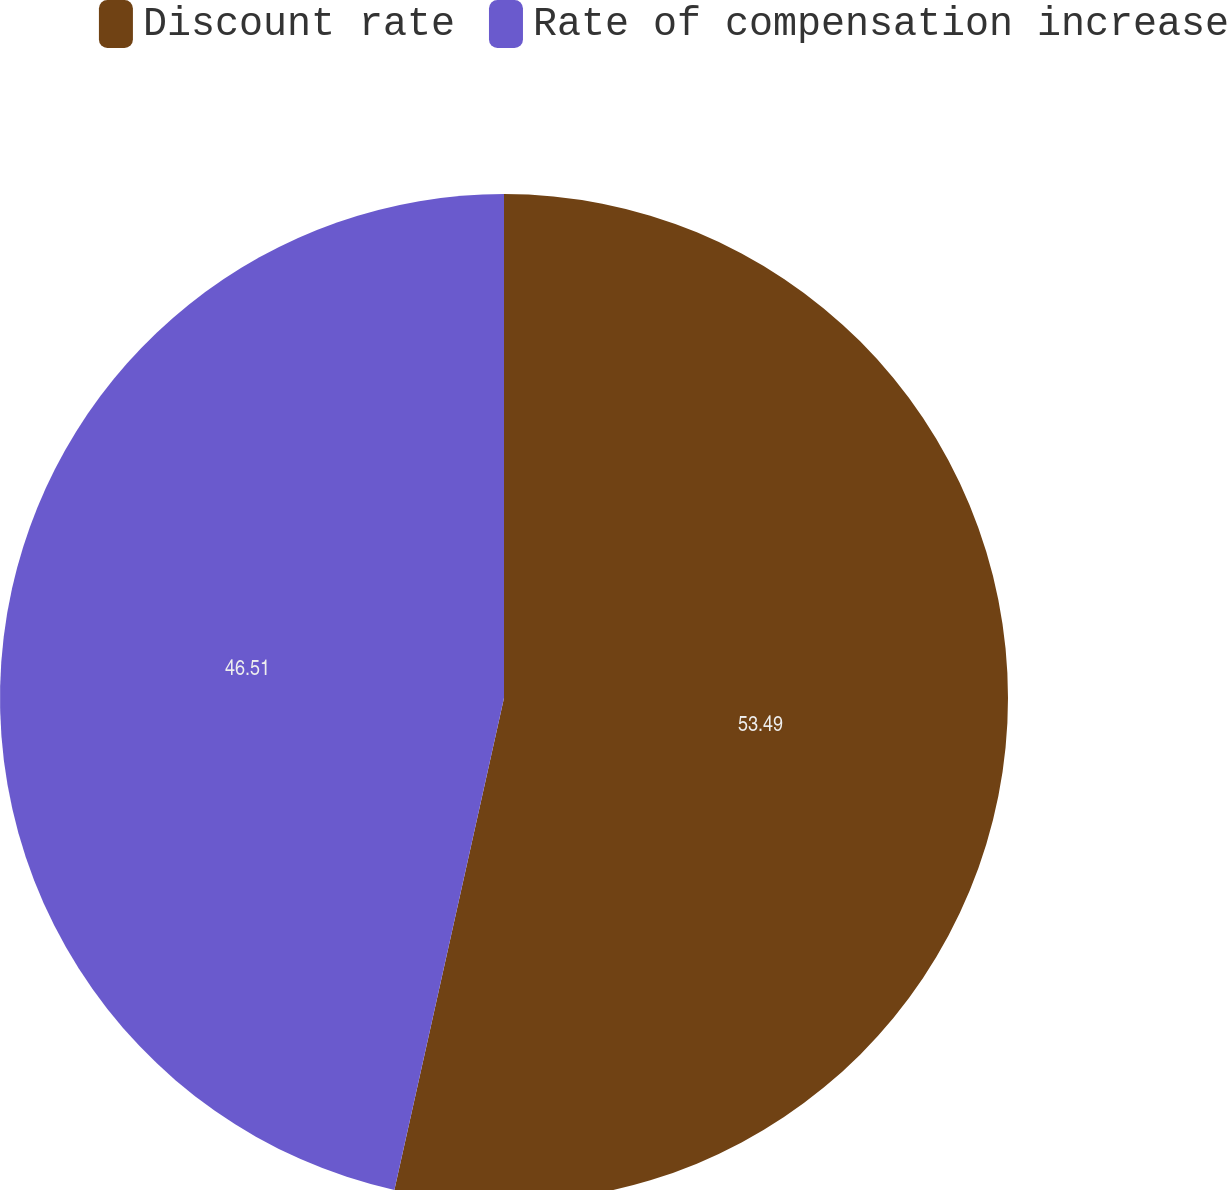<chart> <loc_0><loc_0><loc_500><loc_500><pie_chart><fcel>Discount rate<fcel>Rate of compensation increase<nl><fcel>53.49%<fcel>46.51%<nl></chart> 